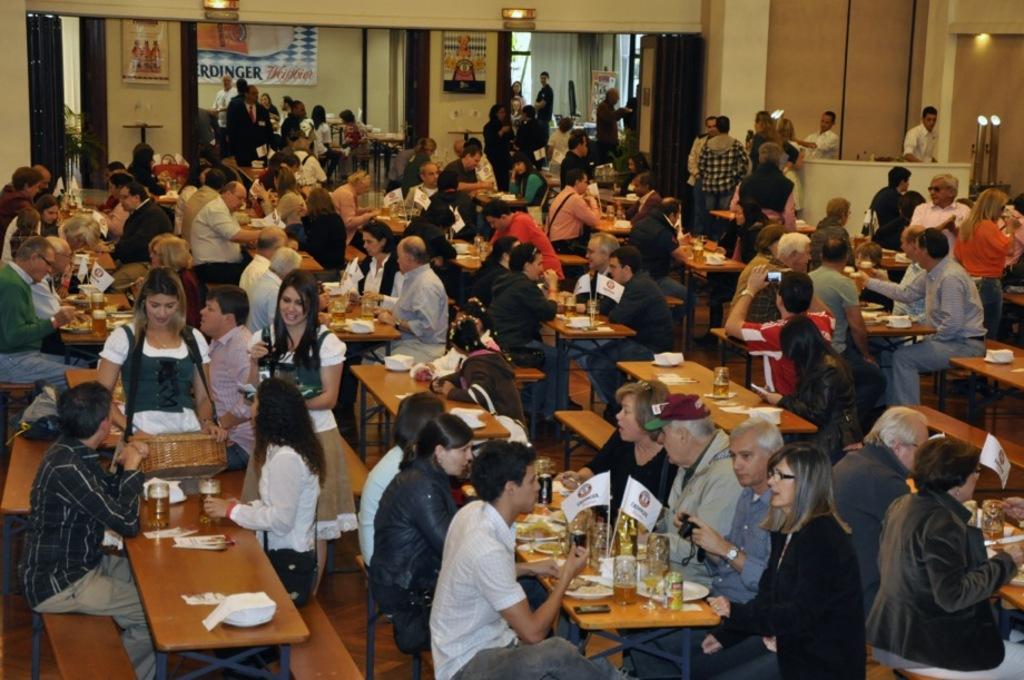Describe this image in one or two sentences. In the image we can see group of peoples were sitting on the chair around the table. On table we can see food items. In the front we can see three persons were standing. Coming to the background we can see some peoples were standing and we can see wall and some sign boards. 